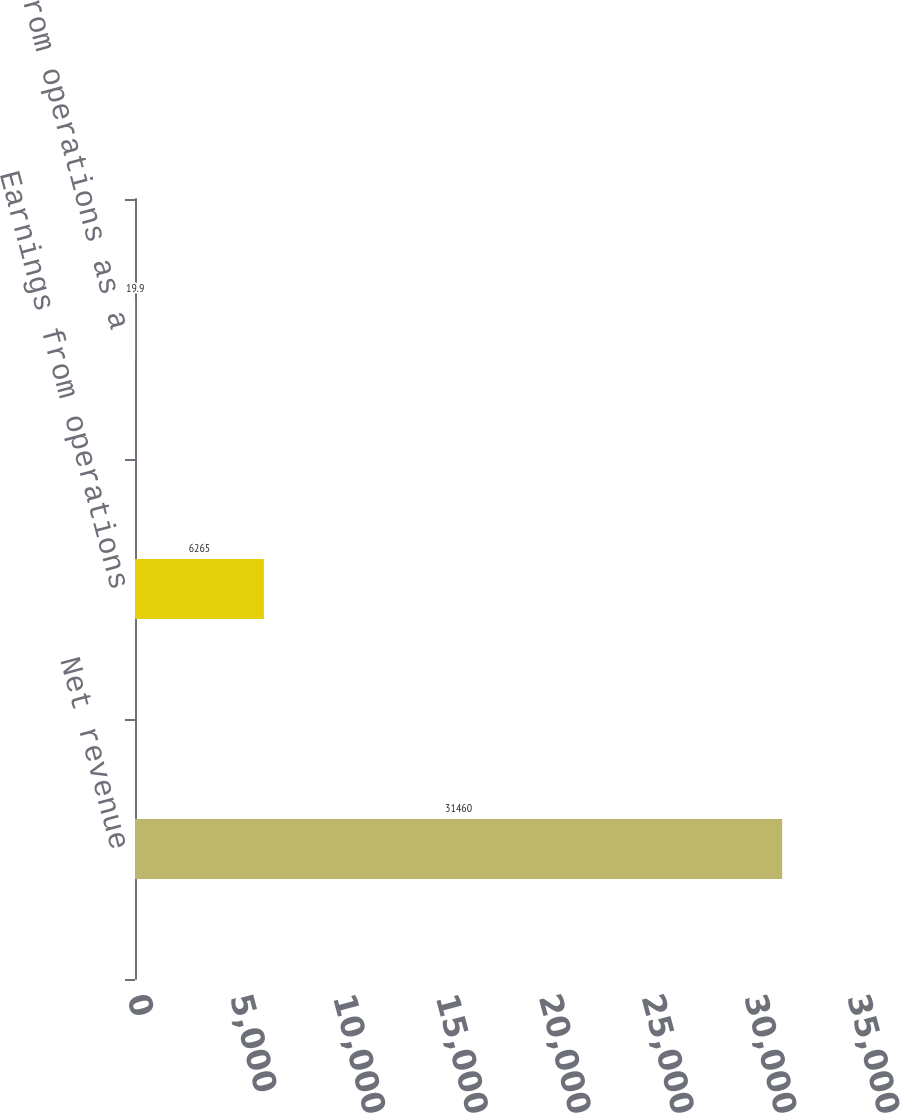Convert chart. <chart><loc_0><loc_0><loc_500><loc_500><bar_chart><fcel>Net revenue<fcel>Earnings from operations<fcel>Earnings from operations as a<nl><fcel>31460<fcel>6265<fcel>19.9<nl></chart> 